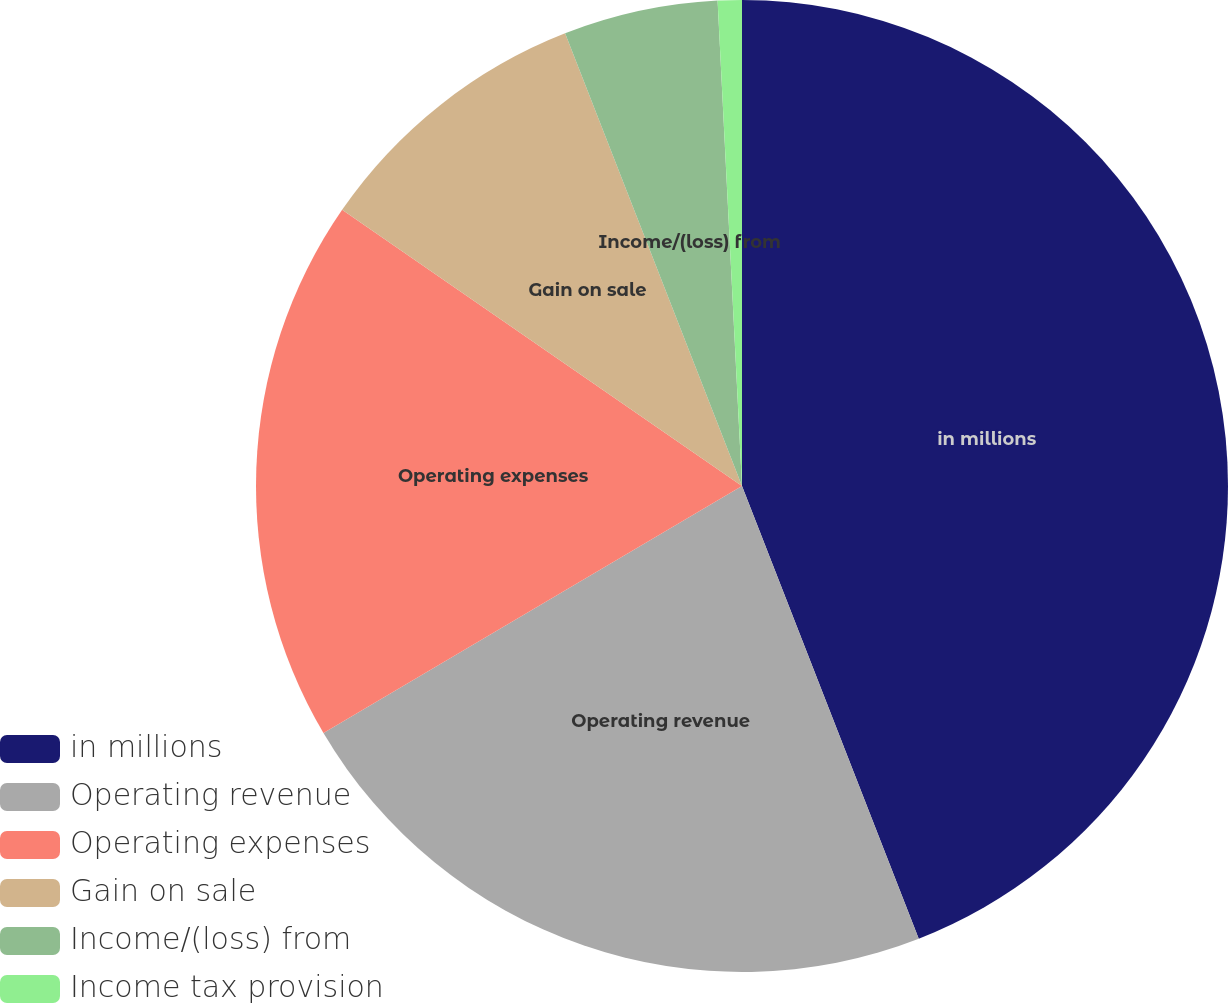Convert chart to OTSL. <chart><loc_0><loc_0><loc_500><loc_500><pie_chart><fcel>in millions<fcel>Operating revenue<fcel>Operating expenses<fcel>Gain on sale<fcel>Income/(loss) from<fcel>Income tax provision<nl><fcel>44.08%<fcel>22.44%<fcel>18.11%<fcel>9.45%<fcel>5.13%<fcel>0.8%<nl></chart> 